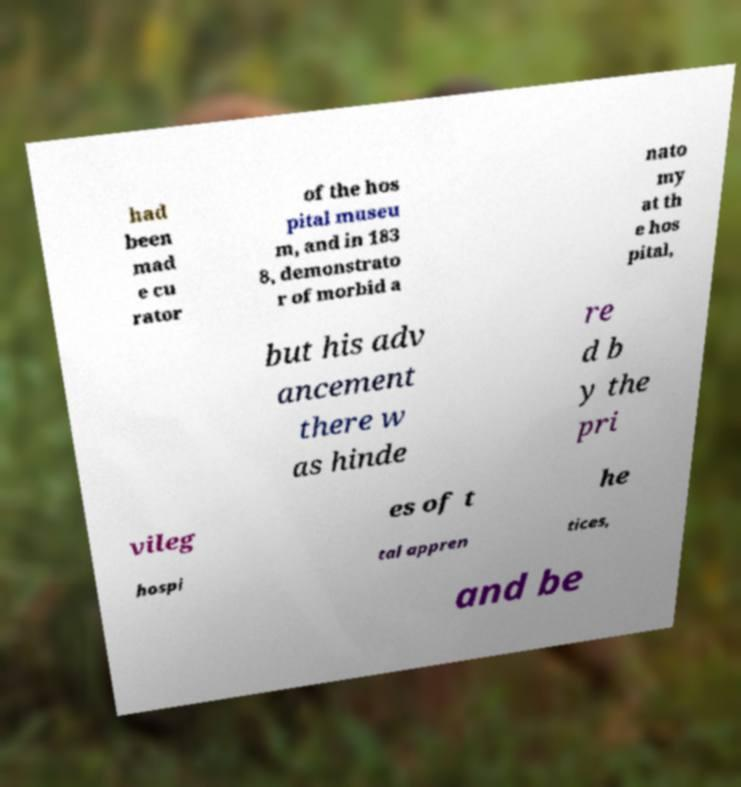There's text embedded in this image that I need extracted. Can you transcribe it verbatim? had been mad e cu rator of the hos pital museu m, and in 183 8, demonstrato r of morbid a nato my at th e hos pital, but his adv ancement there w as hinde re d b y the pri vileg es of t he hospi tal appren tices, and be 